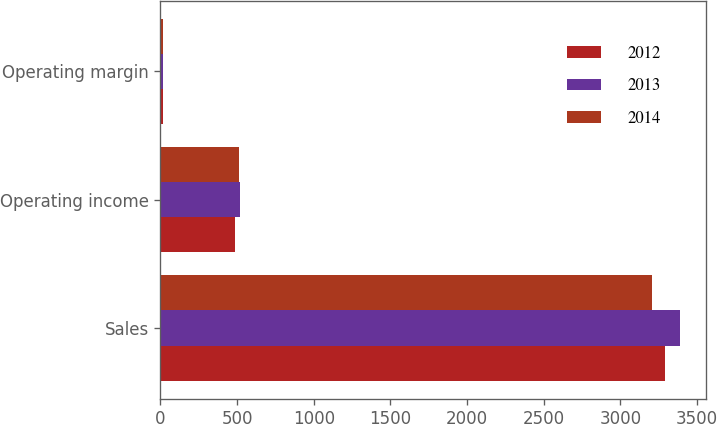Convert chart. <chart><loc_0><loc_0><loc_500><loc_500><stacked_bar_chart><ecel><fcel>Sales<fcel>Operating income<fcel>Operating margin<nl><fcel>2012<fcel>3288.9<fcel>484.9<fcel>14.7<nl><fcel>2013<fcel>3387.3<fcel>515.9<fcel>15.2<nl><fcel>2014<fcel>3206.7<fcel>512<fcel>16<nl></chart> 